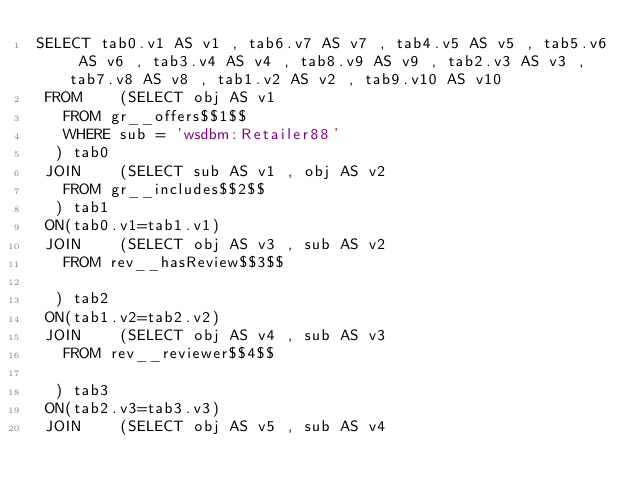Convert code to text. <code><loc_0><loc_0><loc_500><loc_500><_SQL_>SELECT tab0.v1 AS v1 , tab6.v7 AS v7 , tab4.v5 AS v5 , tab5.v6 AS v6 , tab3.v4 AS v4 , tab8.v9 AS v9 , tab2.v3 AS v3 , tab7.v8 AS v8 , tab1.v2 AS v2 , tab9.v10 AS v10 
 FROM    (SELECT obj AS v1 
	 FROM gr__offers$$1$$ 
	 WHERE sub = 'wsdbm:Retailer88'
	) tab0
 JOIN    (SELECT sub AS v1 , obj AS v2 
	 FROM gr__includes$$2$$
	) tab1
 ON(tab0.v1=tab1.v1)
 JOIN    (SELECT obj AS v3 , sub AS v2 
	 FROM rev__hasReview$$3$$
	
	) tab2
 ON(tab1.v2=tab2.v2)
 JOIN    (SELECT obj AS v4 , sub AS v3 
	 FROM rev__reviewer$$4$$
	
	) tab3
 ON(tab2.v3=tab3.v3)
 JOIN    (SELECT obj AS v5 , sub AS v4 </code> 